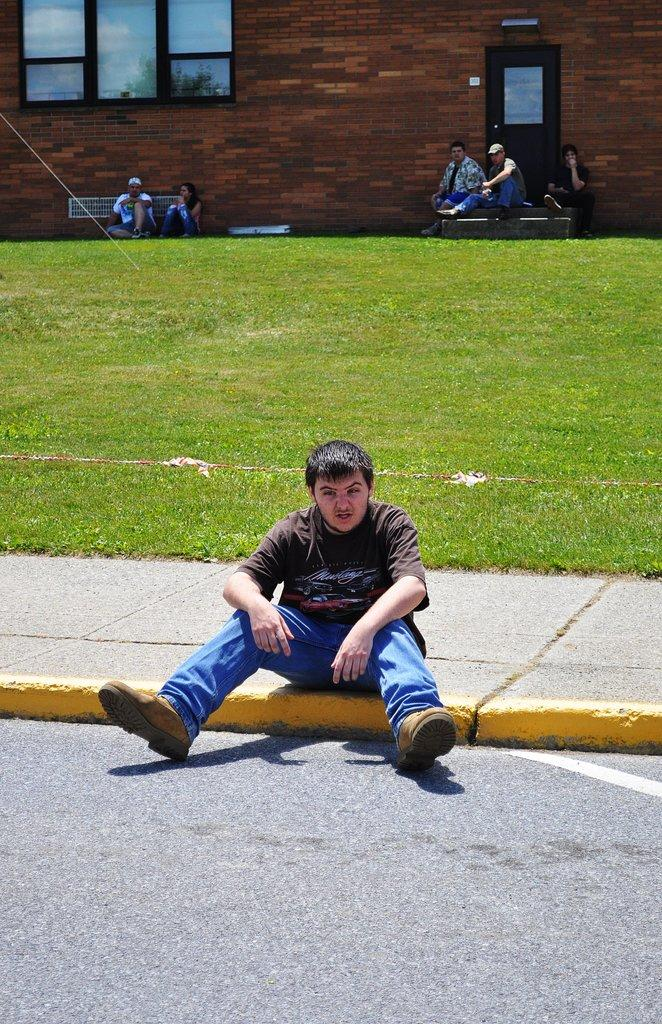What is the man in the image doing? The man is sitting on the walkway in the image. What type of vegetation can be seen in the image? There is grass visible in the image. What can be seen in the background of the image? There are other people and a building in the backdrop of the image. What time does the clock show in the image? There is no clock present in the image. On which side of the man is the cat sitting in the image? There is no cat present in the image. 